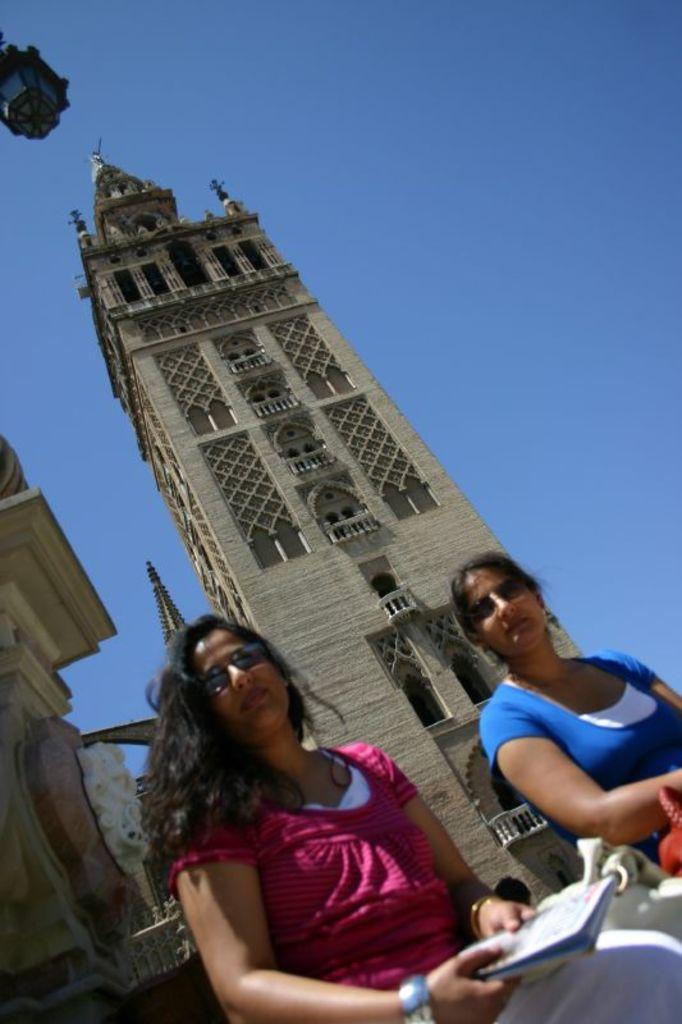What structures are present in the image? There are buildings in the image. What are the two women in the image doing? The two women are sitting in the image. What can be seen in the background of the image? The sky is visible in the background of the image. How many wings can be seen on the women in the image? There are no wings visible on the women in the image. What type of car is parked near the buildings in the image? There is no car present in the image. 